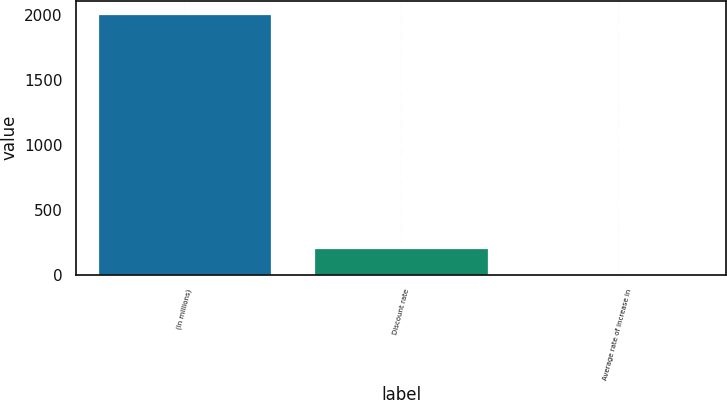<chart> <loc_0><loc_0><loc_500><loc_500><bar_chart><fcel>(In millions)<fcel>Discount rate<fcel>Average rate of increase in<nl><fcel>2012<fcel>203.85<fcel>2.94<nl></chart> 